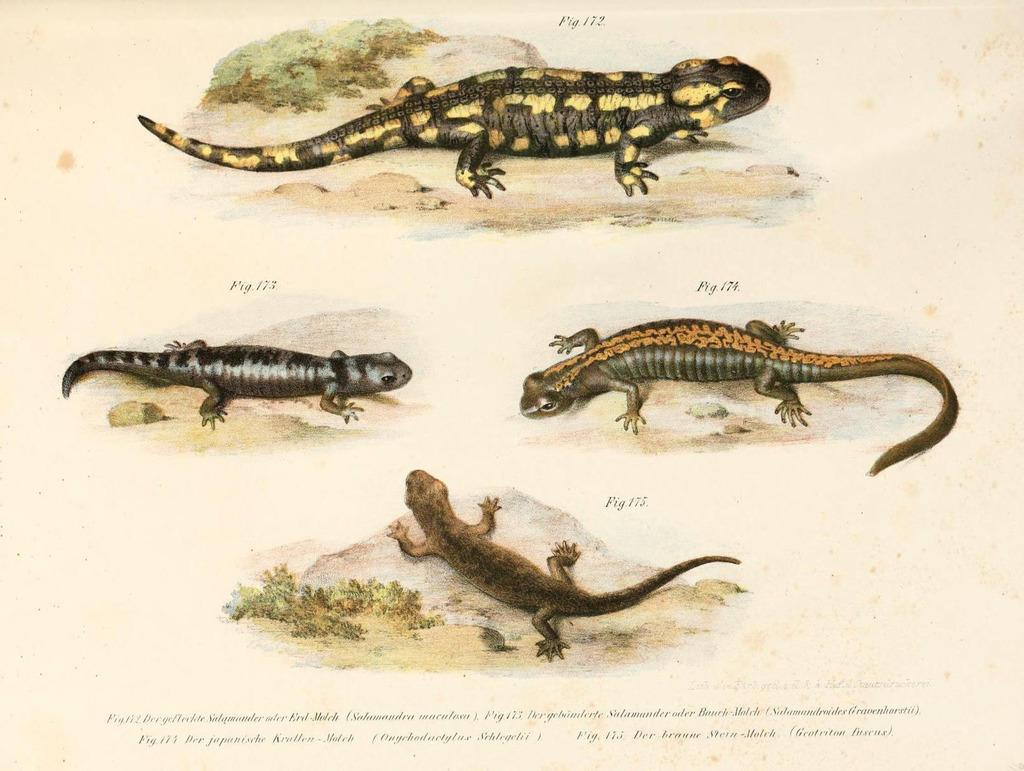What type of visual medium is the image? The image appears to be a poster. What kind of animals are featured in the poster? There are reptiles depicted in the image. Is there any text present in the image? Yes, there is text at the bottom of the image. What is the position of the worm in the image? There is no worm present in the image. How many airports can be seen in the image? There are no airports depicted in the image. 